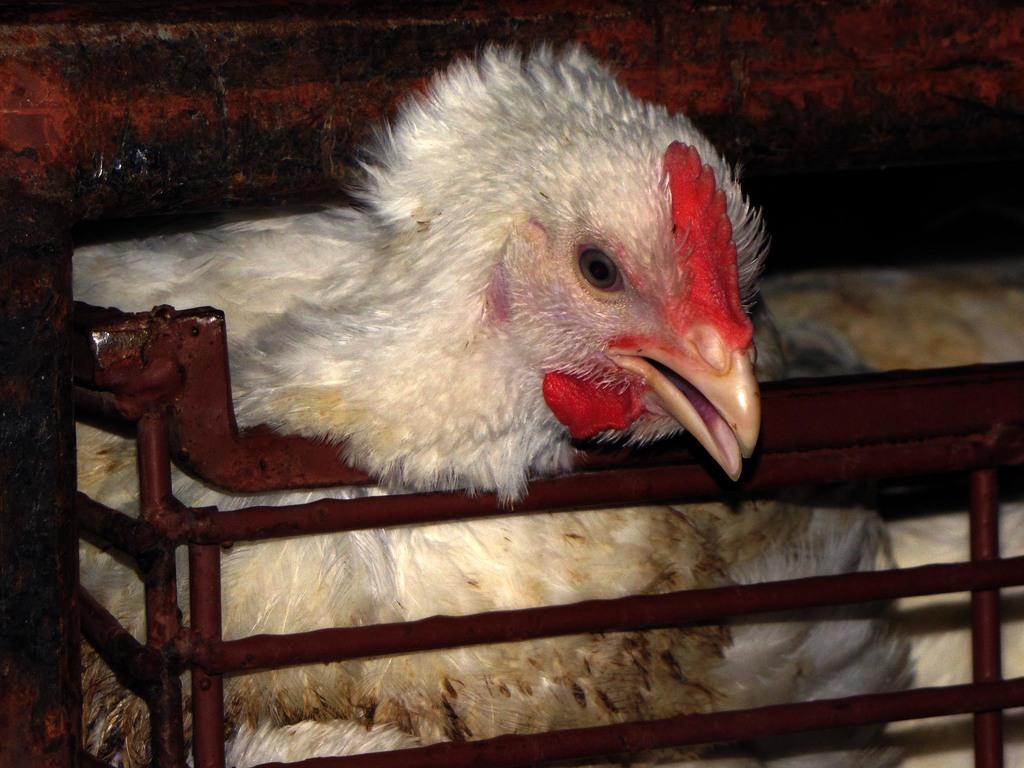Can you describe this image briefly? In the picture I can see a hen which has a fence below and above its head. 